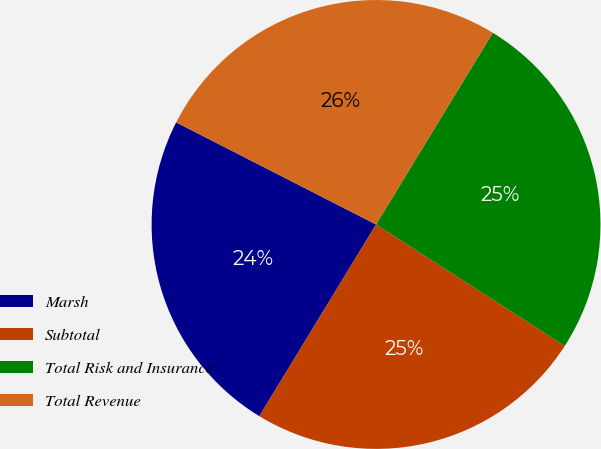Convert chart. <chart><loc_0><loc_0><loc_500><loc_500><pie_chart><fcel>Marsh<fcel>Subtotal<fcel>Total Risk and Insurance<fcel>Total Revenue<nl><fcel>23.81%<fcel>24.6%<fcel>25.4%<fcel>26.19%<nl></chart> 